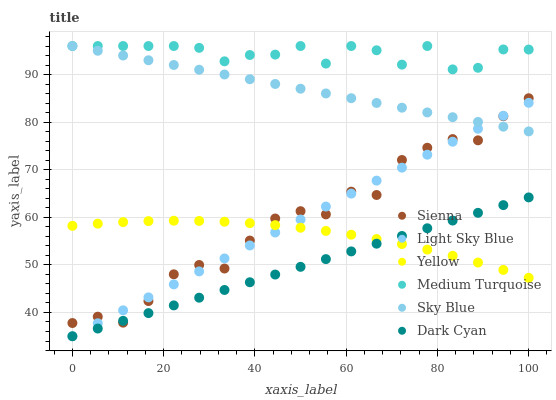Does Dark Cyan have the minimum area under the curve?
Answer yes or no. Yes. Does Medium Turquoise have the maximum area under the curve?
Answer yes or no. Yes. Does Sienna have the minimum area under the curve?
Answer yes or no. No. Does Sienna have the maximum area under the curve?
Answer yes or no. No. Is Light Sky Blue the smoothest?
Answer yes or no. Yes. Is Sienna the roughest?
Answer yes or no. Yes. Is Sienna the smoothest?
Answer yes or no. No. Is Light Sky Blue the roughest?
Answer yes or no. No. Does Light Sky Blue have the lowest value?
Answer yes or no. Yes. Does Sienna have the lowest value?
Answer yes or no. No. Does Sky Blue have the highest value?
Answer yes or no. Yes. Does Sienna have the highest value?
Answer yes or no. No. Is Yellow less than Medium Turquoise?
Answer yes or no. Yes. Is Medium Turquoise greater than Dark Cyan?
Answer yes or no. Yes. Does Medium Turquoise intersect Sky Blue?
Answer yes or no. Yes. Is Medium Turquoise less than Sky Blue?
Answer yes or no. No. Is Medium Turquoise greater than Sky Blue?
Answer yes or no. No. Does Yellow intersect Medium Turquoise?
Answer yes or no. No. 